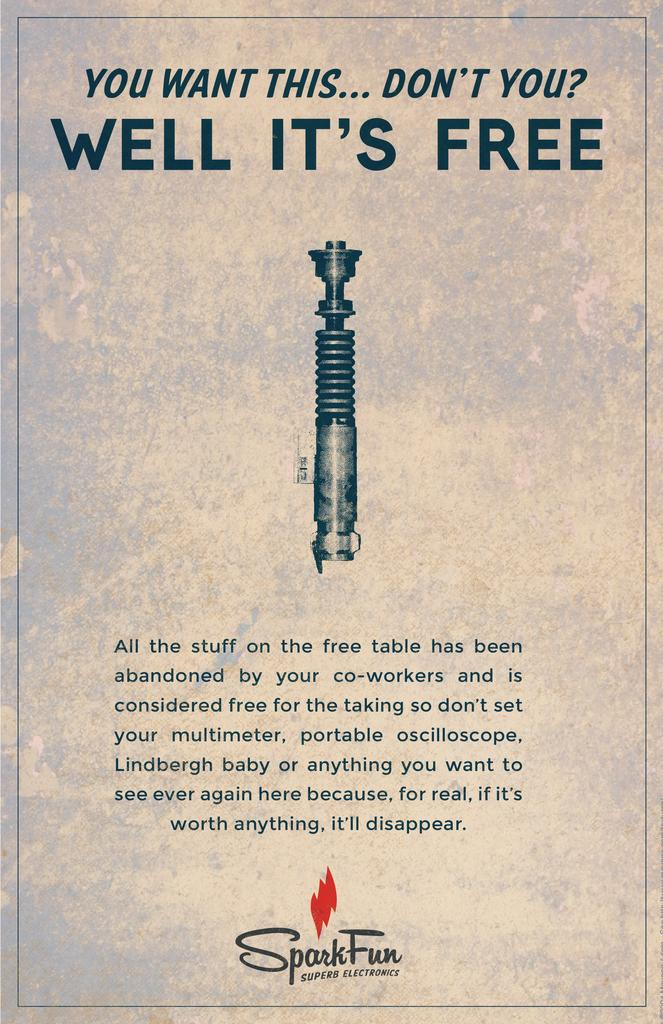<image>
Describe the image concisely. An advertisement for Spark Fun Super Electronics describes a free promotion. 